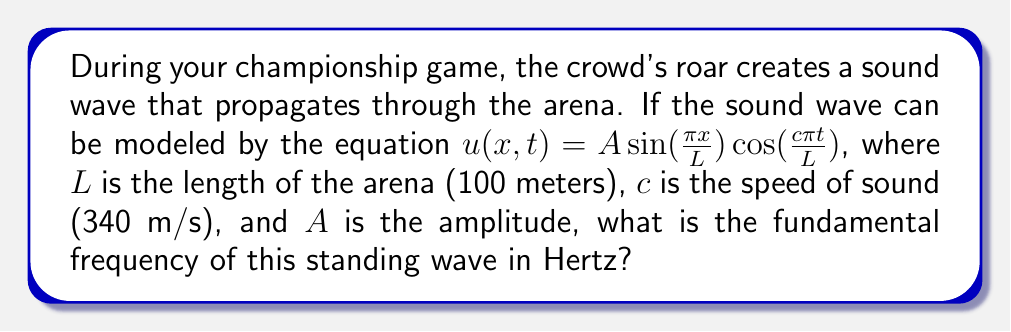Help me with this question. To find the fundamental frequency, we need to follow these steps:

1) The general form of a standing wave equation is:
   $$u(x,t) = A \sin(\frac{n\pi x}{L}) \cos(\frac{n\pi c t}{L})$$
   where $n$ is the mode number.

2) Comparing this to our given equation, we see that $n = 1$, indicating this is the fundamental mode.

3) The frequency $f$ is related to the angular frequency $\omega$ by:
   $$f = \frac{\omega}{2\pi}$$

4) From the cosine term in our equation, we can identify that:
   $$\omega = \frac{c\pi}{L}$$

5) Substituting this into the frequency equation:
   $$f = \frac{c\pi}{2\pi L} = \frac{c}{2L}$$

6) Now we can plug in our values:
   $$f = \frac{340 \text{ m/s}}{2(100 \text{ m})} = 1.7 \text{ Hz}$$

Therefore, the fundamental frequency of the standing wave is 1.7 Hz.
Answer: 1.7 Hz 